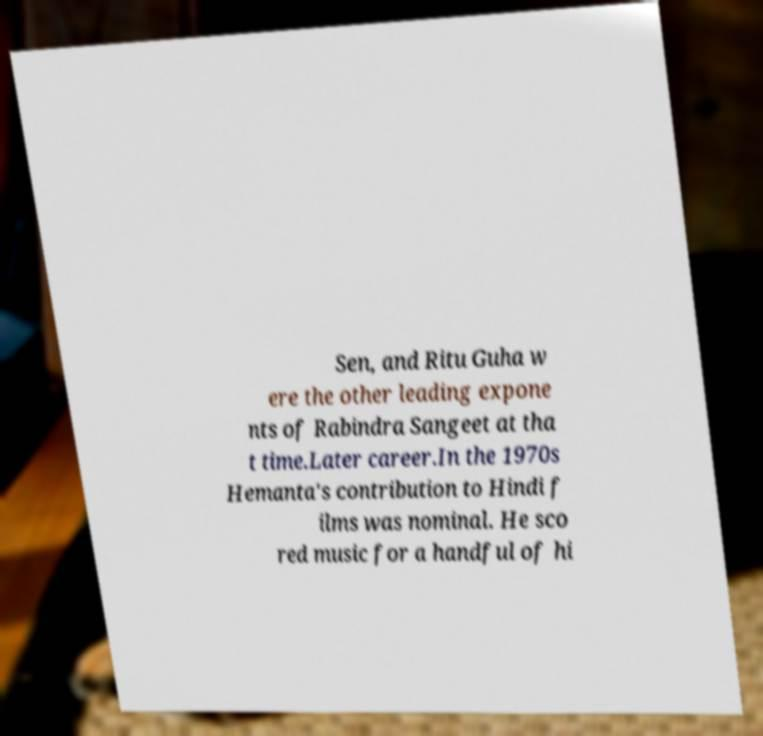There's text embedded in this image that I need extracted. Can you transcribe it verbatim? Sen, and Ritu Guha w ere the other leading expone nts of Rabindra Sangeet at tha t time.Later career.In the 1970s Hemanta's contribution to Hindi f ilms was nominal. He sco red music for a handful of hi 